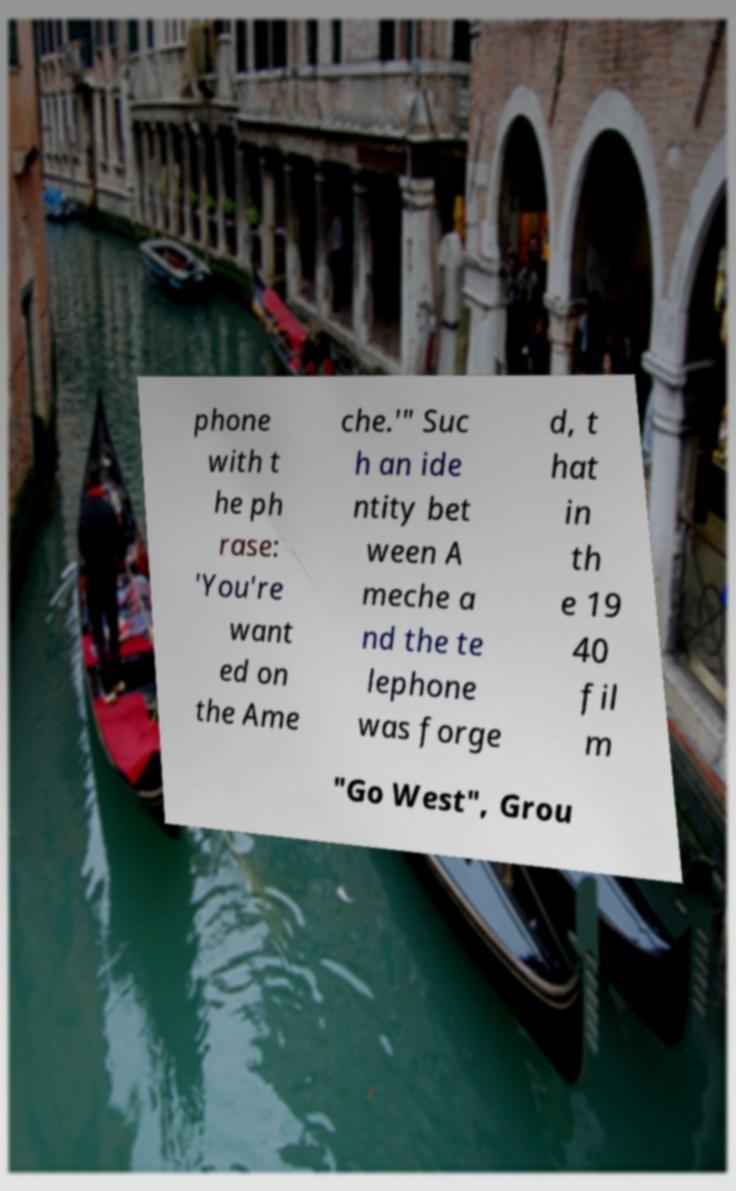Please identify and transcribe the text found in this image. phone with t he ph rase: 'You're want ed on the Ame che.'" Suc h an ide ntity bet ween A meche a nd the te lephone was forge d, t hat in th e 19 40 fil m "Go West", Grou 